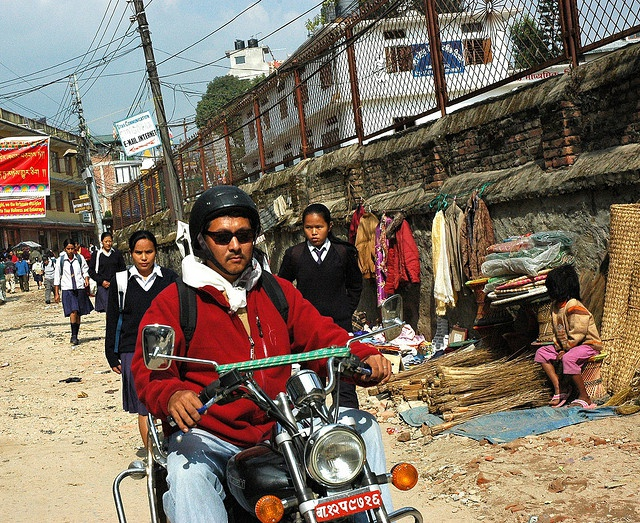Describe the objects in this image and their specific colors. I can see people in lightblue, black, brown, maroon, and white tones, motorcycle in lightblue, black, gray, white, and brown tones, people in lightblue, black, white, and maroon tones, people in lightblue, black, maroon, brown, and white tones, and people in lightblue, black, maroon, brown, and tan tones in this image. 